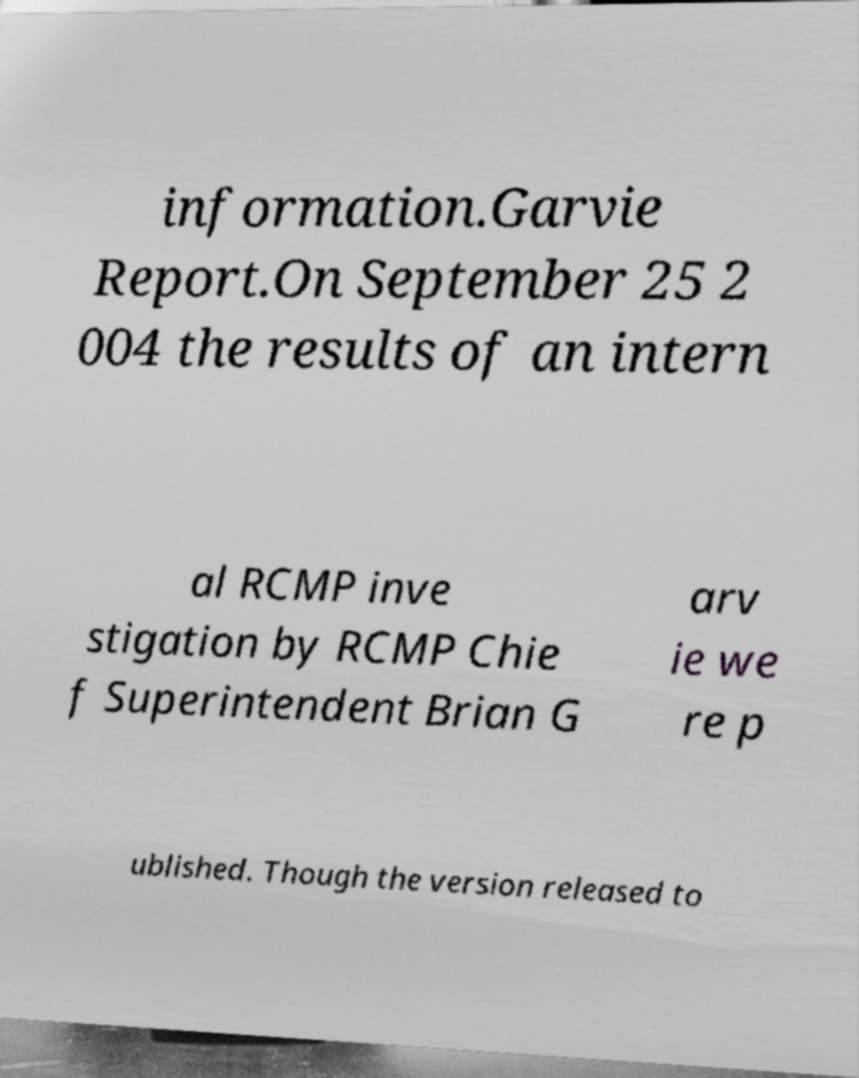Please identify and transcribe the text found in this image. information.Garvie Report.On September 25 2 004 the results of an intern al RCMP inve stigation by RCMP Chie f Superintendent Brian G arv ie we re p ublished. Though the version released to 